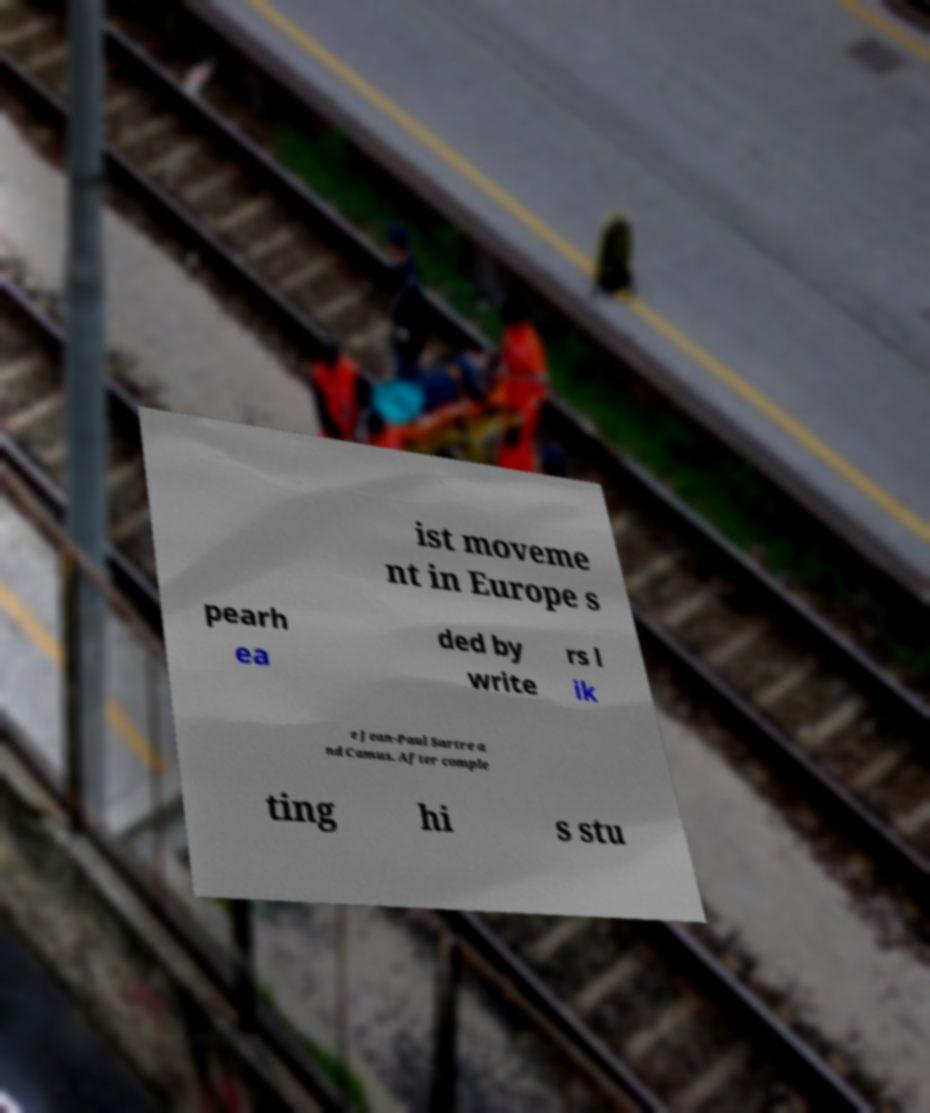There's text embedded in this image that I need extracted. Can you transcribe it verbatim? ist moveme nt in Europe s pearh ea ded by write rs l ik e Jean-Paul Sartre a nd Camus. After comple ting hi s stu 